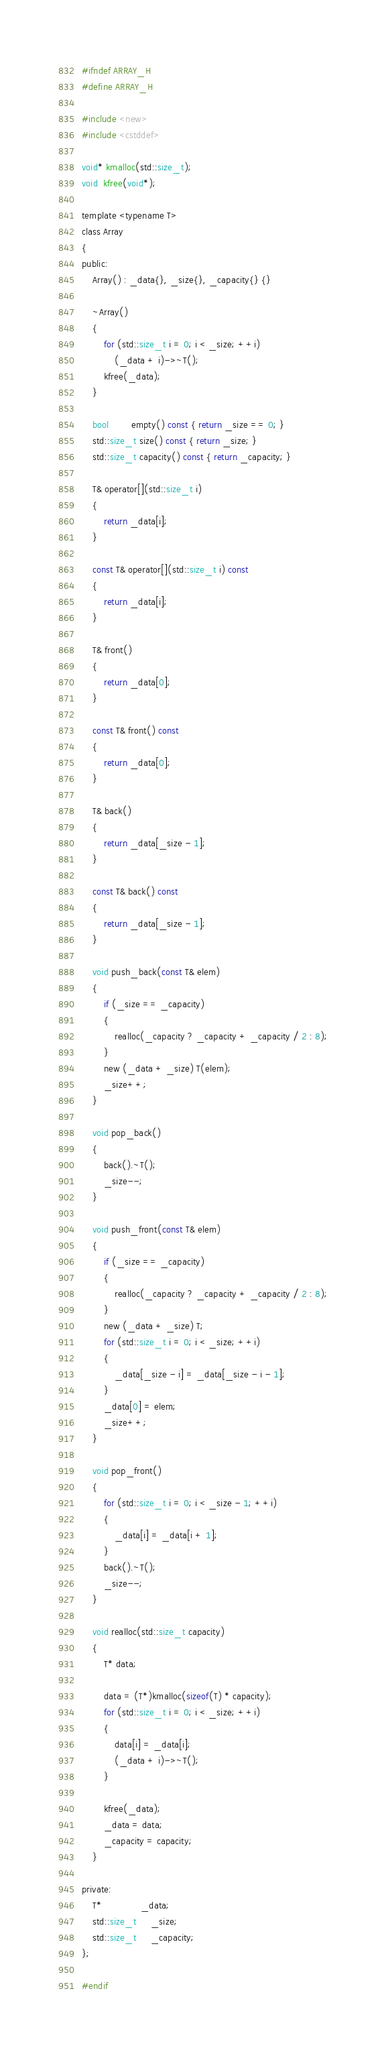<code> <loc_0><loc_0><loc_500><loc_500><_C_>#ifndef ARRAY_H
#define ARRAY_H

#include <new>
#include <cstddef>

void* kmalloc(std::size_t);
void  kfree(void*);

template <typename T>
class Array
{
public:
    Array() : _data{}, _size{}, _capacity{} {}

    ~Array()
    {
        for (std::size_t i = 0; i < _size; ++i)
            (_data + i)->~T();
        kfree(_data);
    }

    bool        empty() const { return _size == 0; }
    std::size_t size() const { return _size; }
    std::size_t capacity() const { return _capacity; }

    T& operator[](std::size_t i)
    {
        return _data[i];
    }

    const T& operator[](std::size_t i) const
    {
        return _data[i];
    }

    T& front()
    {
        return _data[0];
    }

    const T& front() const
    {
        return _data[0];
    }

    T& back()
    {
        return _data[_size - 1];
    }

    const T& back() const
    {
        return _data[_size - 1];
    }

    void push_back(const T& elem)
    {
        if (_size == _capacity)
        {
            realloc(_capacity ? _capacity + _capacity / 2 : 8);
        }
        new (_data + _size) T(elem);
        _size++;
    }

    void pop_back()
    {
        back().~T();
        _size--;
    }

    void push_front(const T& elem)
    {
        if (_size == _capacity)
        {
            realloc(_capacity ? _capacity + _capacity / 2 : 8);
        }
        new (_data + _size) T;
        for (std::size_t i = 0; i < _size; ++i)
        {
            _data[_size - i] = _data[_size - i - 1];
        }
        _data[0] = elem;
        _size++;
    }

    void pop_front()
    {
        for (std::size_t i = 0; i < _size - 1; ++i)
        {
            _data[i] = _data[i + 1];
        }
        back().~T();
        _size--;
    }

    void realloc(std::size_t capacity)
    {
        T* data;

        data = (T*)kmalloc(sizeof(T) * capacity);
        for (std::size_t i = 0; i < _size; ++i)
        {
            data[i] = _data[i];
            (_data + i)->~T();
        }

        kfree(_data);
        _data = data;
        _capacity = capacity;
    }

private:
    T*              _data;
    std::size_t     _size;
    std::size_t     _capacity;
};

#endif
</code> 